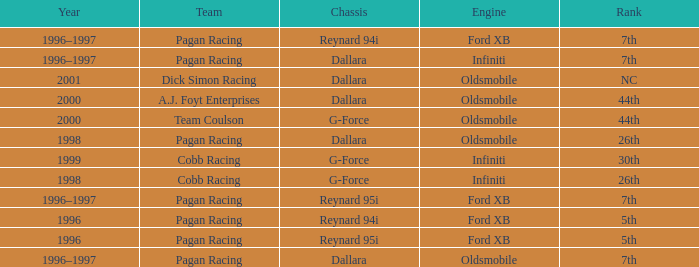What rank did the dallara chassis finish in 2000? 44th. 